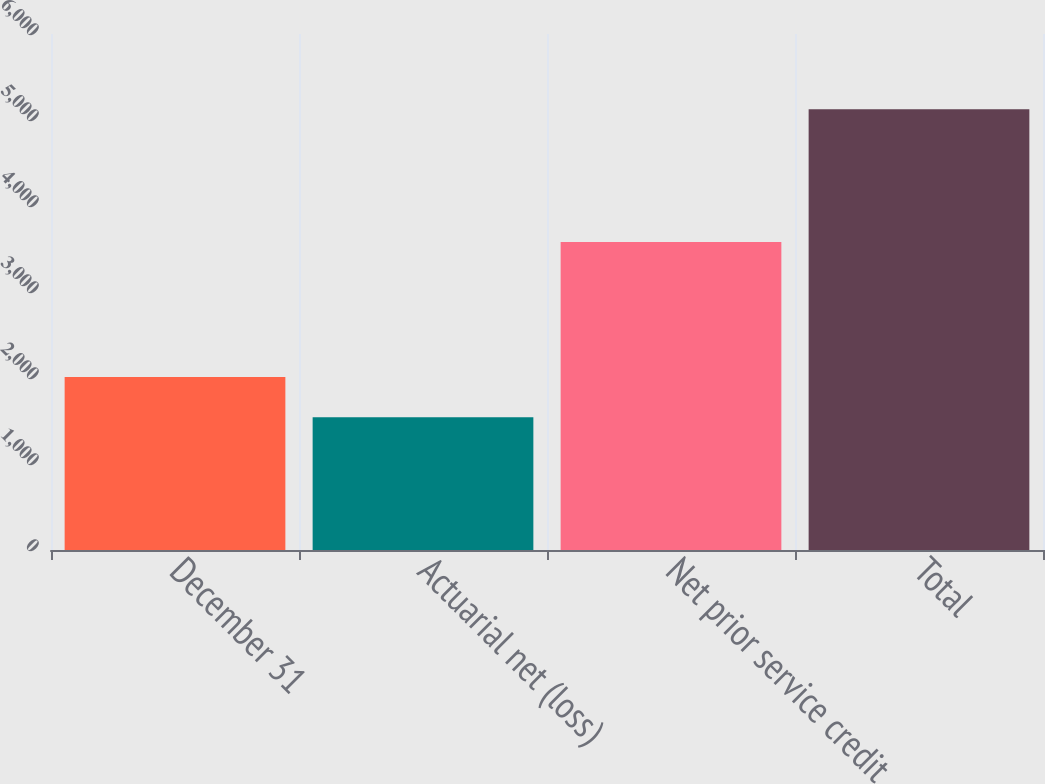Convert chart to OTSL. <chart><loc_0><loc_0><loc_500><loc_500><bar_chart><fcel>December 31<fcel>Actuarial net (loss)<fcel>Net prior service credit<fcel>Total<nl><fcel>2011<fcel>1545<fcel>3580<fcel>5125<nl></chart> 